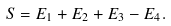<formula> <loc_0><loc_0><loc_500><loc_500>S = E _ { 1 } + E _ { 2 } + E _ { 3 } - E _ { 4 } .</formula> 